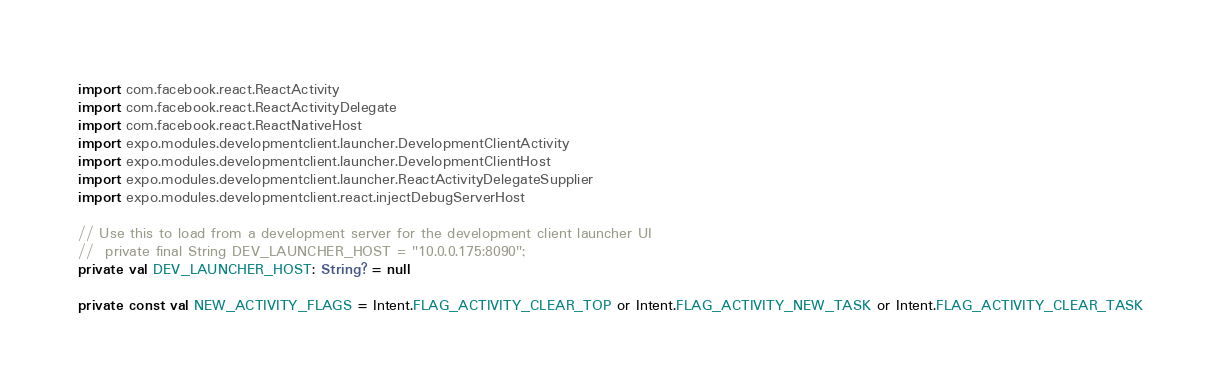Convert code to text. <code><loc_0><loc_0><loc_500><loc_500><_Kotlin_>import com.facebook.react.ReactActivity
import com.facebook.react.ReactActivityDelegate
import com.facebook.react.ReactNativeHost
import expo.modules.developmentclient.launcher.DevelopmentClientActivity
import expo.modules.developmentclient.launcher.DevelopmentClientHost
import expo.modules.developmentclient.launcher.ReactActivityDelegateSupplier
import expo.modules.developmentclient.react.injectDebugServerHost

// Use this to load from a development server for the development client launcher UI
//  private final String DEV_LAUNCHER_HOST = "10.0.0.175:8090";
private val DEV_LAUNCHER_HOST: String? = null

private const val NEW_ACTIVITY_FLAGS = Intent.FLAG_ACTIVITY_CLEAR_TOP or Intent.FLAG_ACTIVITY_NEW_TASK or Intent.FLAG_ACTIVITY_CLEAR_TASK
</code> 